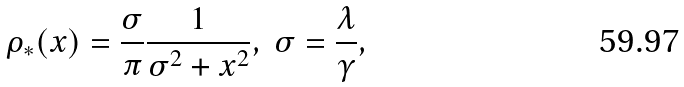<formula> <loc_0><loc_0><loc_500><loc_500>\rho _ { * } ( x ) = \frac { \sigma } { \pi } \frac { 1 } { \sigma ^ { 2 } + x ^ { 2 } } , \ \sigma = \frac { \lambda } { \gamma } ,</formula> 